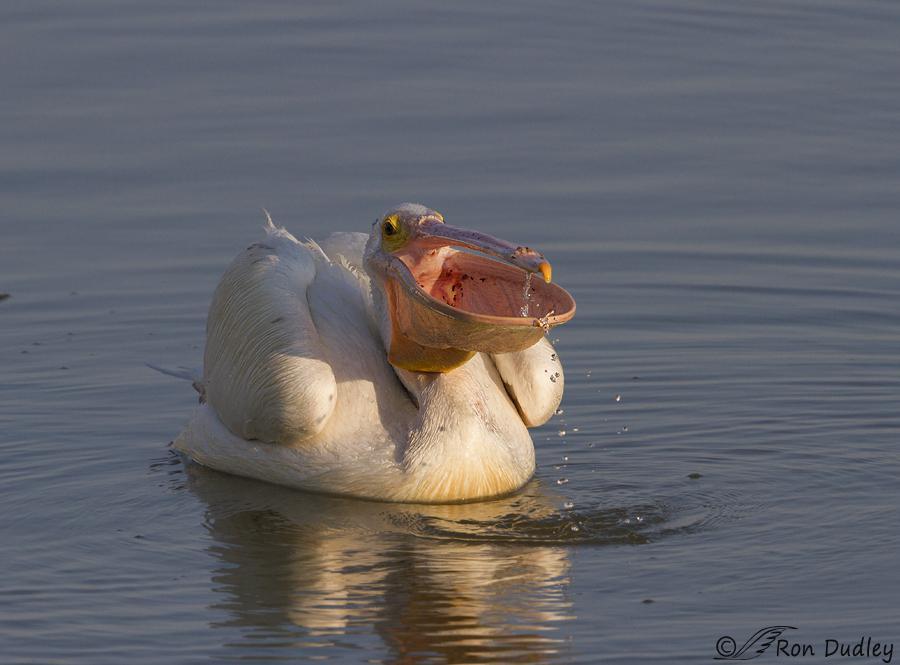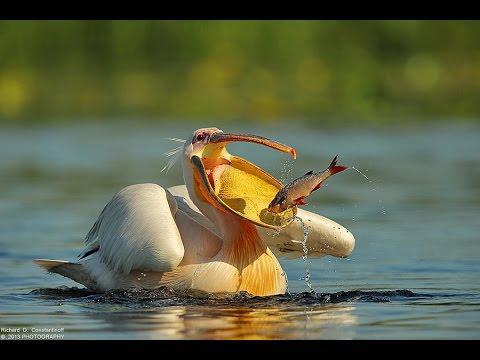The first image is the image on the left, the second image is the image on the right. For the images shown, is this caption "An image shows a left-facing dark pelican that has a fish in its bill." true? Answer yes or no. No. The first image is the image on the left, the second image is the image on the right. Given the left and right images, does the statement "The bird is facing the left as it eats its food." hold true? Answer yes or no. No. 